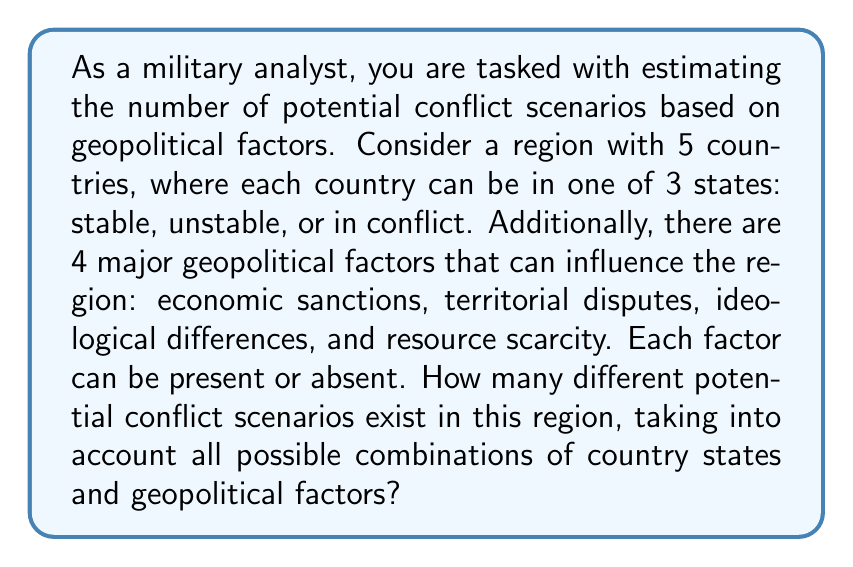Show me your answer to this math problem. To solve this problem, we need to use the multiplication principle of counting. We'll break down the problem into two parts: the number of possible combinations of country states and the number of possible combinations of geopolitical factors.

1. Country states:
   - There are 5 countries, each with 3 possible states.
   - The number of possible combinations for country states is $3^5$.

2. Geopolitical factors:
   - There are 4 factors, each can be present or absent (2 possibilities).
   - The number of possible combinations for geopolitical factors is $2^4$.

Now, we multiply these two results to get the total number of potential conflict scenarios:

$$ \text{Total scenarios} = (\text{Country state combinations}) \times (\text{Geopolitical factor combinations}) $$

$$ \text{Total scenarios} = 3^5 \times 2^4 $$

Let's calculate each part:

$3^5 = 3 \times 3 \times 3 \times 3 \times 3 = 243$

$2^4 = 2 \times 2 \times 2 \times 2 = 16$

Now, we multiply these results:

$$ \text{Total scenarios} = 243 \times 16 = 3,888 $$

Therefore, there are 3,888 different potential conflict scenarios in this region, considering all possible combinations of country states and geopolitical factors.
Answer: 3,888 potential conflict scenarios 